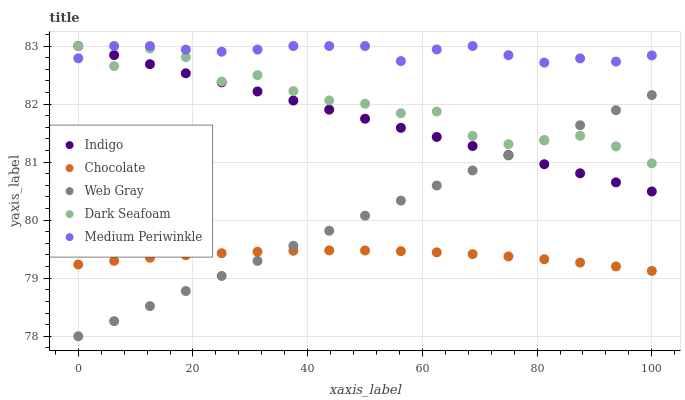Does Chocolate have the minimum area under the curve?
Answer yes or no. Yes. Does Medium Periwinkle have the maximum area under the curve?
Answer yes or no. Yes. Does Dark Seafoam have the minimum area under the curve?
Answer yes or no. No. Does Dark Seafoam have the maximum area under the curve?
Answer yes or no. No. Is Web Gray the smoothest?
Answer yes or no. Yes. Is Dark Seafoam the roughest?
Answer yes or no. Yes. Is Dark Seafoam the smoothest?
Answer yes or no. No. Is Web Gray the roughest?
Answer yes or no. No. Does Web Gray have the lowest value?
Answer yes or no. Yes. Does Dark Seafoam have the lowest value?
Answer yes or no. No. Does Indigo have the highest value?
Answer yes or no. Yes. Does Web Gray have the highest value?
Answer yes or no. No. Is Chocolate less than Medium Periwinkle?
Answer yes or no. Yes. Is Medium Periwinkle greater than Chocolate?
Answer yes or no. Yes. Does Indigo intersect Web Gray?
Answer yes or no. Yes. Is Indigo less than Web Gray?
Answer yes or no. No. Is Indigo greater than Web Gray?
Answer yes or no. No. Does Chocolate intersect Medium Periwinkle?
Answer yes or no. No. 